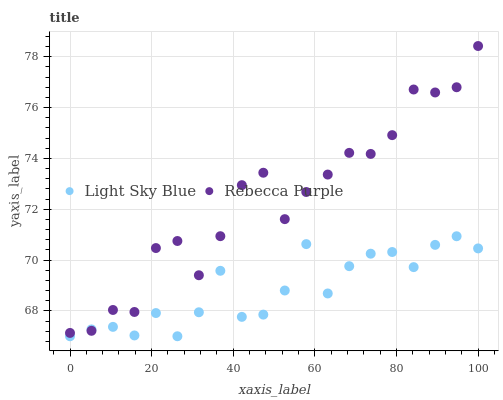Does Light Sky Blue have the minimum area under the curve?
Answer yes or no. Yes. Does Rebecca Purple have the maximum area under the curve?
Answer yes or no. Yes. Does Rebecca Purple have the minimum area under the curve?
Answer yes or no. No. Is Light Sky Blue the smoothest?
Answer yes or no. Yes. Is Rebecca Purple the roughest?
Answer yes or no. Yes. Is Rebecca Purple the smoothest?
Answer yes or no. No. Does Light Sky Blue have the lowest value?
Answer yes or no. Yes. Does Rebecca Purple have the lowest value?
Answer yes or no. No. Does Rebecca Purple have the highest value?
Answer yes or no. Yes. Does Rebecca Purple intersect Light Sky Blue?
Answer yes or no. Yes. Is Rebecca Purple less than Light Sky Blue?
Answer yes or no. No. Is Rebecca Purple greater than Light Sky Blue?
Answer yes or no. No. 